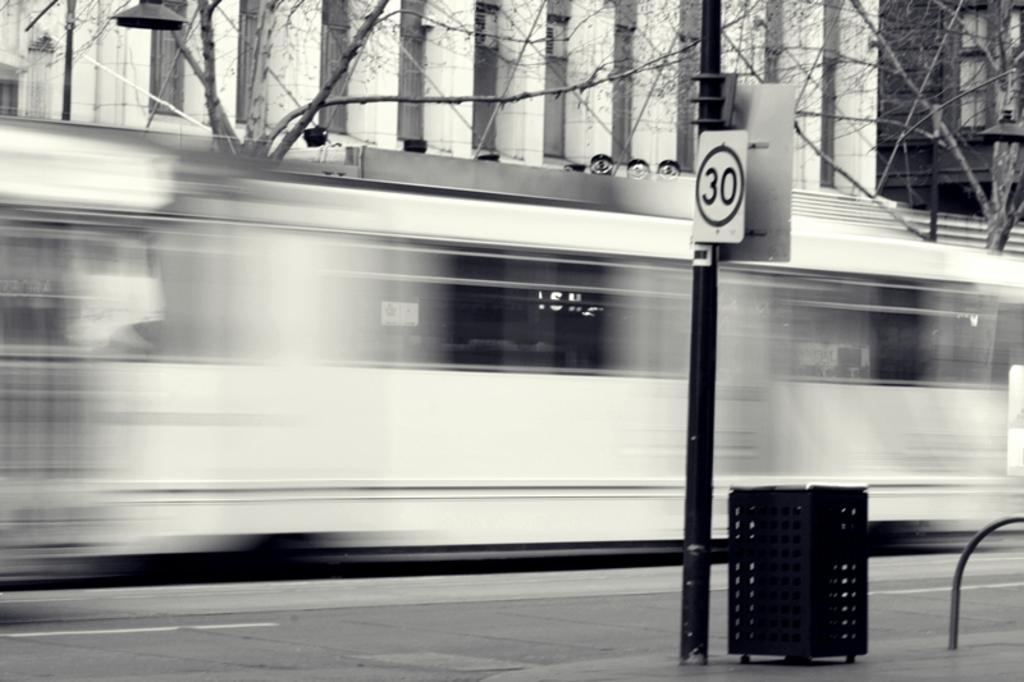What is the color scheme of the image? The image is black and white. What can be seen moving on the road in the image? There is a vehicle passing on the road in the image. What type of natural elements are present in the image? Trees are present in the image. What type of man-made structures are visible in the image? Buildings are visible in the image. What is the tall, vertical object in the image? There is a pole in the image. How does the stone contribute to the digestion process in the image? There is no stone present in the image, and therefore no digestion process can be observed. What is the existence of the image trying to convey? The existence of the image is simply to provide a visual representation of the scene, and it does not convey any specific message or meaning. 